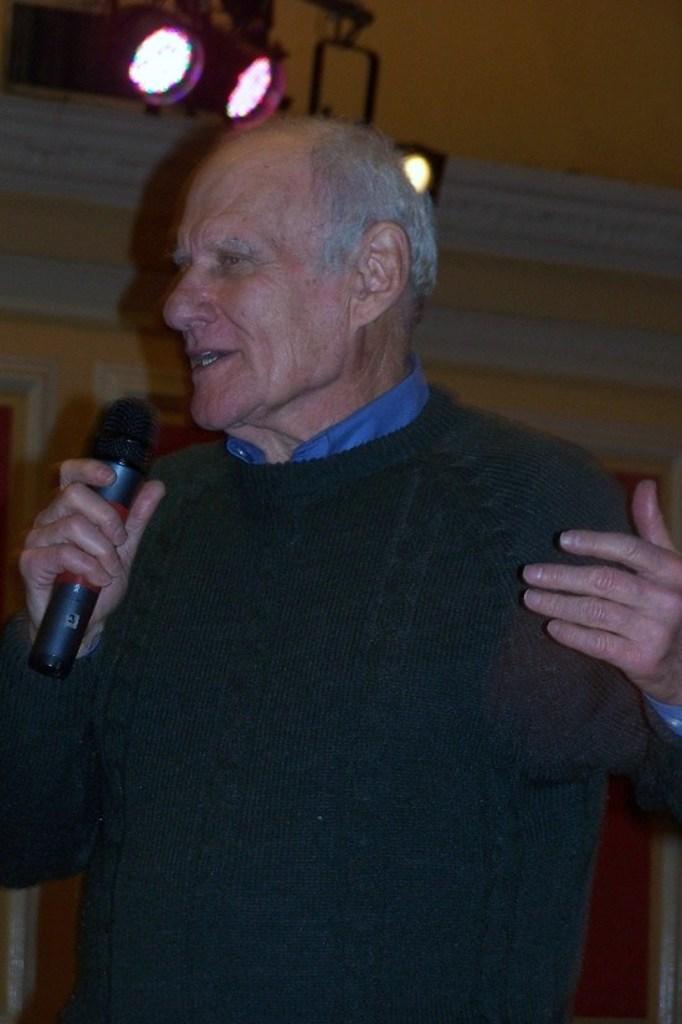How would you summarize this image in a sentence or two? in the picture a person is singing a song by holding a microphone in his hand. 